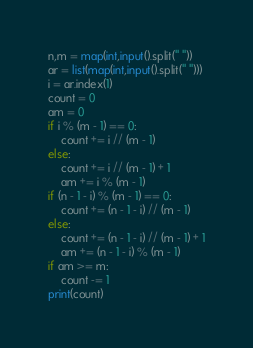<code> <loc_0><loc_0><loc_500><loc_500><_Python_>n,m = map(int,input().split(" "))
ar = list(map(int,input().split(" ")))
i = ar.index(1)
count = 0
am = 0
if i % (m - 1) == 0:
    count += i // (m - 1)
else:
    count += i // (m - 1) + 1
    am += i % (m - 1)
if (n - 1 - i) % (m - 1) == 0:
    count += (n - 1 - i) // (m - 1)
else:
    count += (n - 1 - i) // (m - 1) + 1
    am += (n - 1 - i) % (m - 1)
if am >= m:
    count -= 1
print(count)</code> 